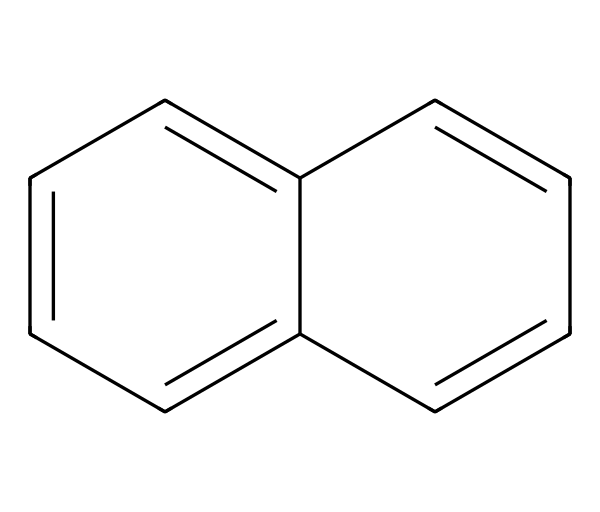What is the molecular formula of naphthalene? The structure of naphthalene shows two fused benzene rings, and by counting the carbon and hydrogen atoms, we see there are 10 carbon atoms and 8 hydrogen atoms. Therefore, the molecular formula is C10H8.
Answer: C10H8 How many rings are present in naphthalene? The structure of naphthalene reveals two interconnected cyclic structures, specifically two fused aromatic benzene rings, indicating the presence of two rings in total.
Answer: 2 What type of bonding is present in naphthalene? The structure consists of alternating double bonds within the aromatic rings, which indicate the presence of resonance and delocalized pi bonds typical of aromatic compounds, thus categorizing the bonding primarily as covalent and resonance bonding.
Answer: covalent What is the primary use of naphthalene in mothballs? The primary function of naphthalene in mothballs is as a moth repellent due to its volatile nature and ability to sublimate, which helps to protect textiles and collectibles from moth damage.
Answer: moth repellent Is naphthalene polar or nonpolar? The symmetrical structure of naphthalene with its evenly distributed electrons results in a nonpolar molecule, as there are no significant dipoles present.
Answer: nonpolar How many hydrogen atoms are attached to naphthalene? From the molecular formula C10H8, we identify that there are a total of 8 hydrogen atoms connected to the carbon framework of the naphthalene structure.
Answer: 8 